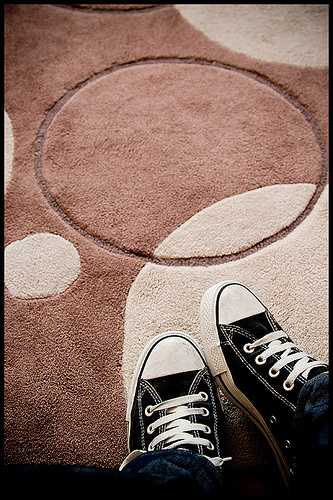<image>
Is there a shoes in front of the rug? No. The shoes is not in front of the rug. The spatial positioning shows a different relationship between these objects. 